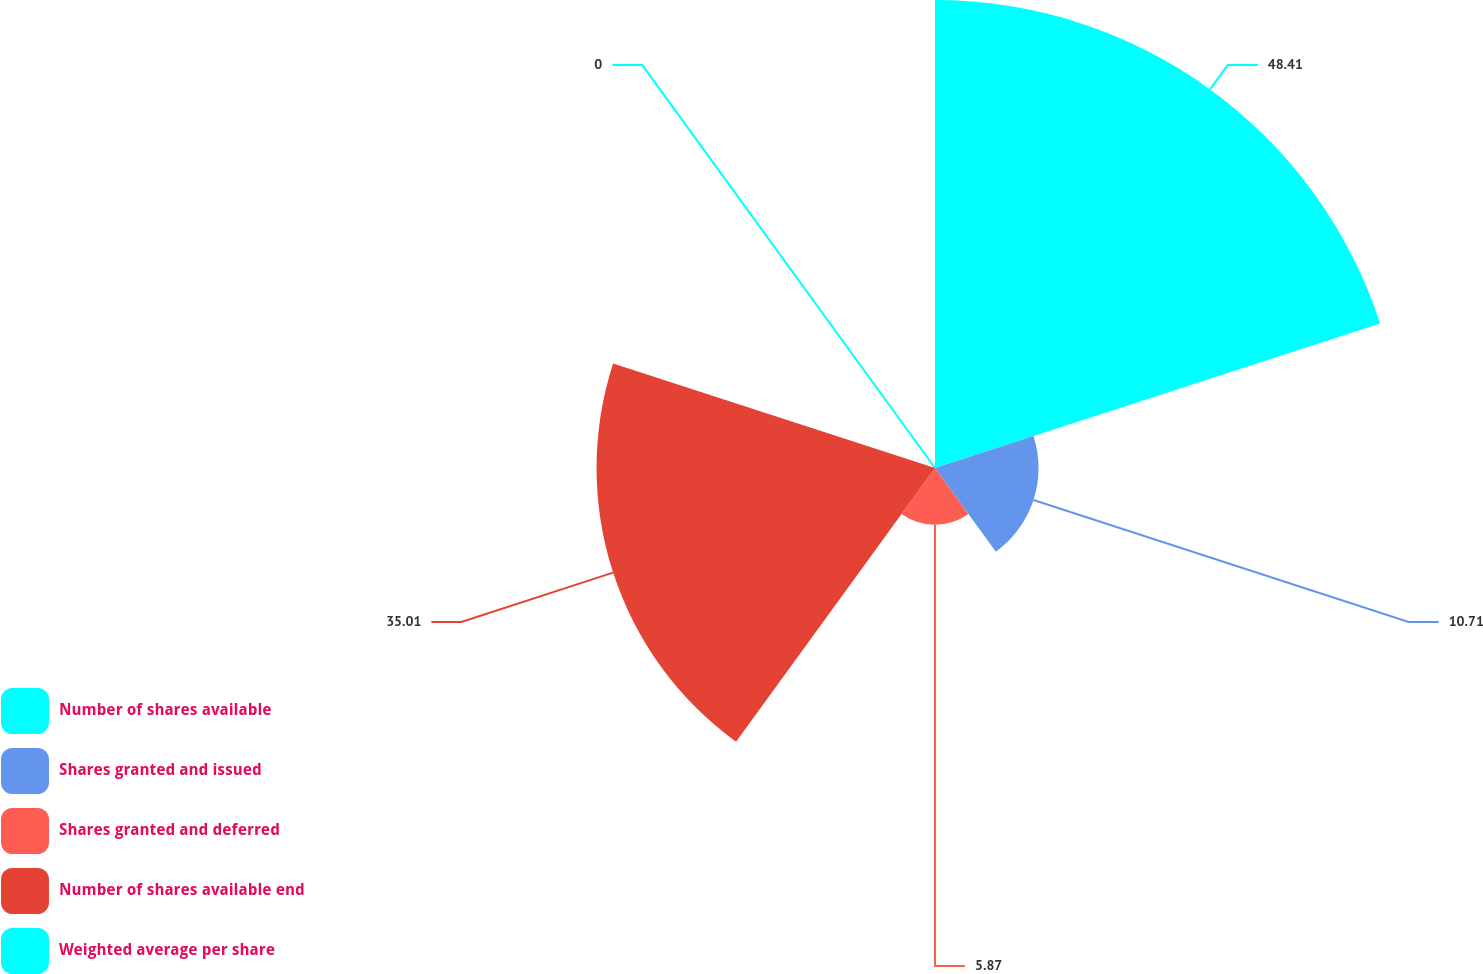Convert chart. <chart><loc_0><loc_0><loc_500><loc_500><pie_chart><fcel>Number of shares available<fcel>Shares granted and issued<fcel>Shares granted and deferred<fcel>Number of shares available end<fcel>Weighted average per share<nl><fcel>48.41%<fcel>10.71%<fcel>5.87%<fcel>35.01%<fcel>0.0%<nl></chart> 